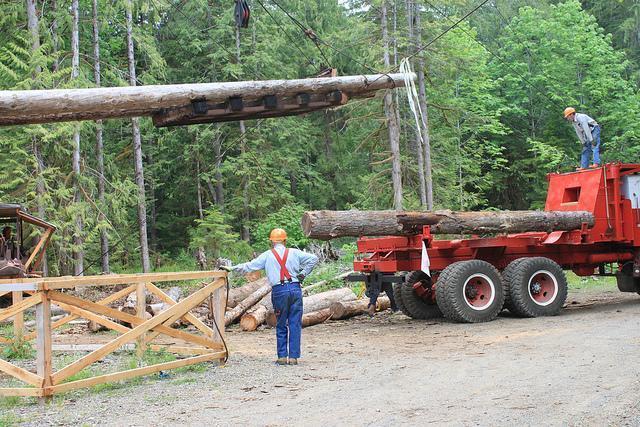How many boats are there?
Give a very brief answer. 0. 